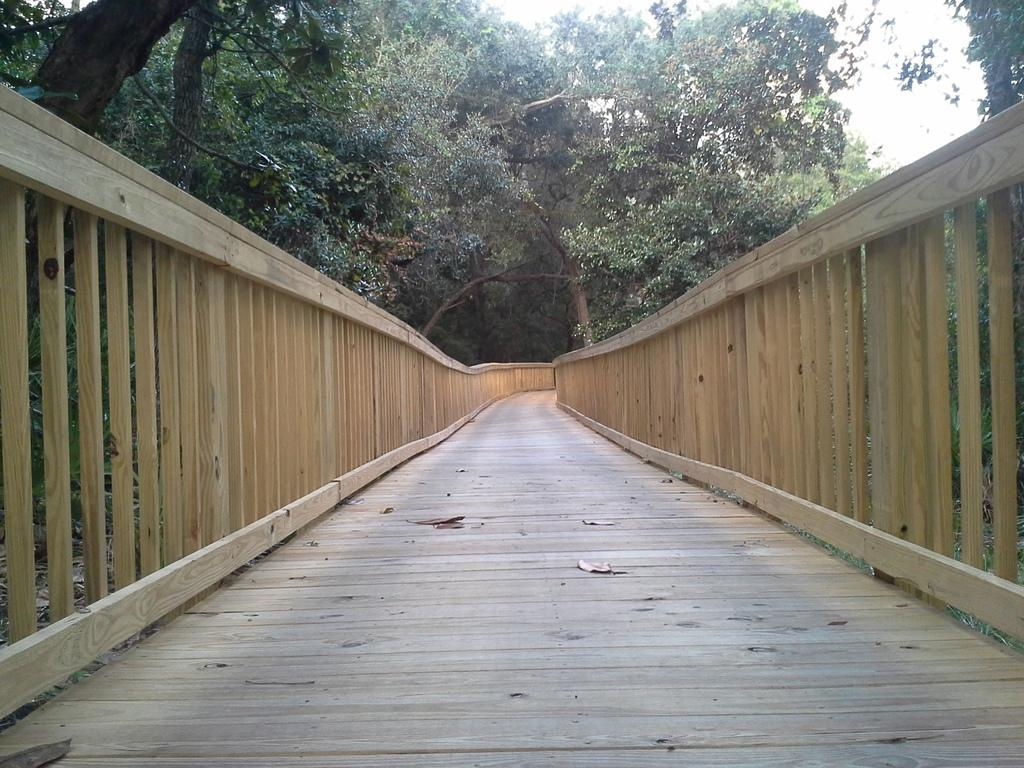What is on the path in the image? There are dried leaves on a path in the image. What type of structures can be seen in the image? There are fences in the image. What type of vegetation is present in the image? There are trees in the image. What can be seen in the background of the image? The sky is visible in the background of the image. Can you tell me where the horse is located in the image? There is no horse present in the image. What type of sail is attached to the trees in the image? There are no sails or boats present in the image; it features dried leaves on a path, fences, trees, and a visible sky. 